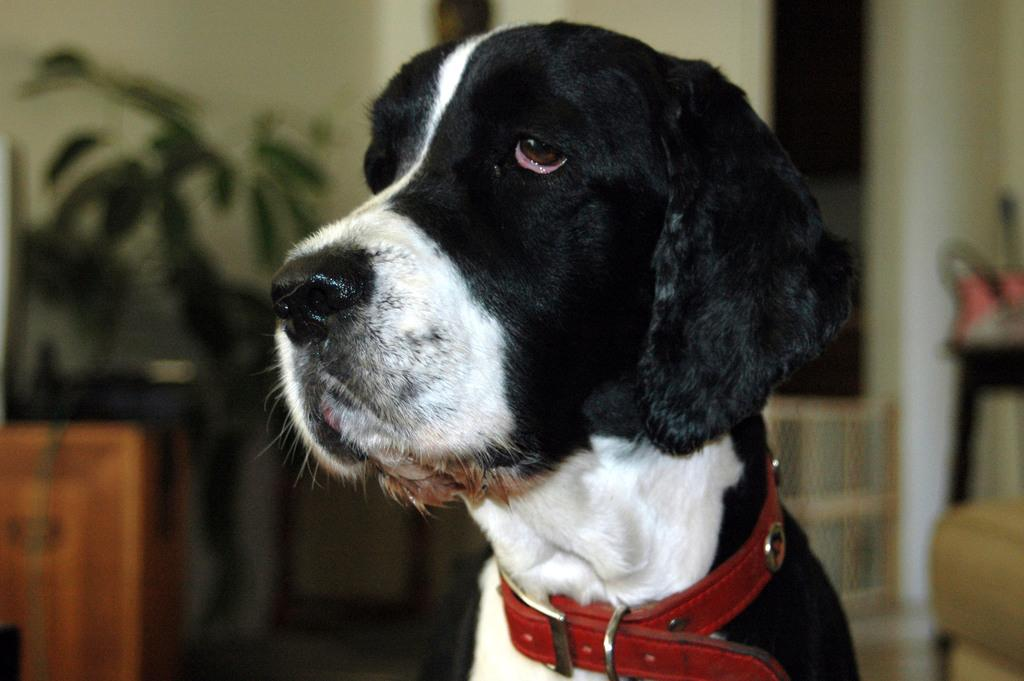What type of animal can be seen in the image? There is a dog in the image. What is on the table in the image? There are potted plants on a table. Can you describe any other objects in the image? There are other objects in the image, but their specific details are not mentioned in the provided facts. What can be seen in the background of the image? There is a wall visible in the background of the image. What type of shoe is the deer wearing in the image? There is no deer or shoe present in the image; it features a dog and potted plants on a table. 